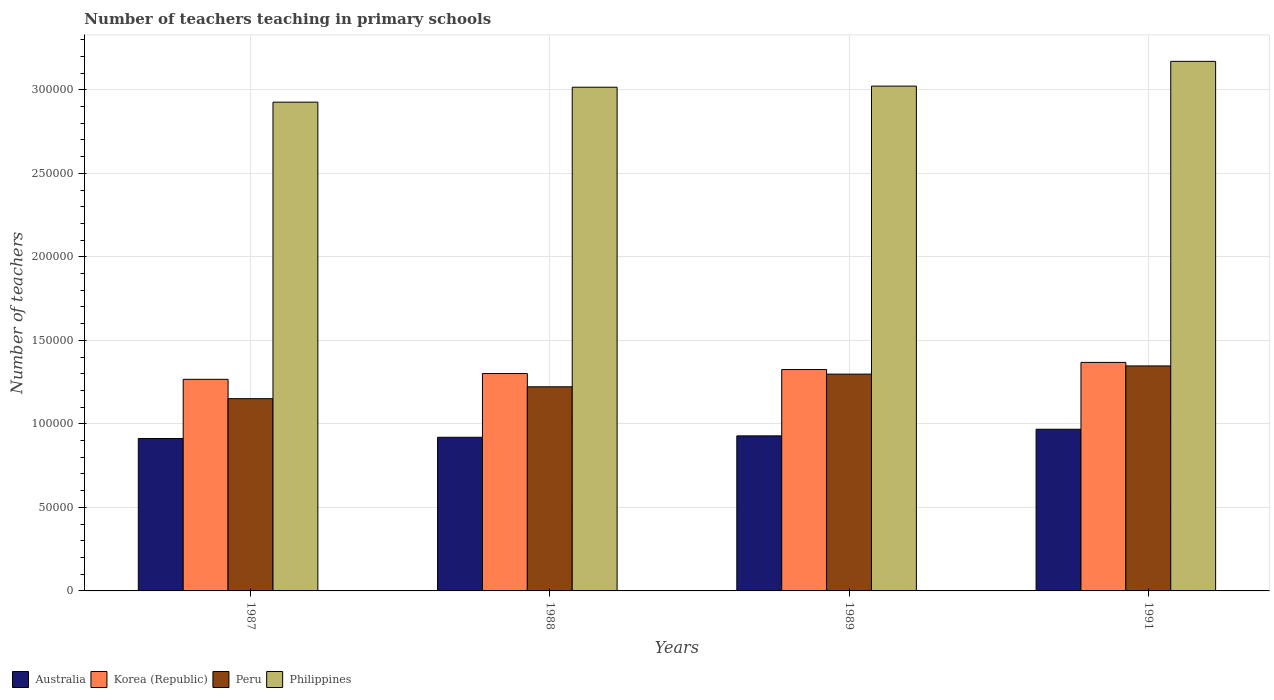How many different coloured bars are there?
Give a very brief answer. 4. How many groups of bars are there?
Keep it short and to the point. 4. How many bars are there on the 4th tick from the left?
Your answer should be very brief. 4. In how many cases, is the number of bars for a given year not equal to the number of legend labels?
Keep it short and to the point. 0. What is the number of teachers teaching in primary schools in Korea (Republic) in 1987?
Make the answer very short. 1.27e+05. Across all years, what is the maximum number of teachers teaching in primary schools in Australia?
Your answer should be very brief. 9.68e+04. Across all years, what is the minimum number of teachers teaching in primary schools in Philippines?
Make the answer very short. 2.93e+05. What is the total number of teachers teaching in primary schools in Philippines in the graph?
Your answer should be very brief. 1.21e+06. What is the difference between the number of teachers teaching in primary schools in Peru in 1987 and that in 1988?
Your response must be concise. -7106. What is the difference between the number of teachers teaching in primary schools in Korea (Republic) in 1987 and the number of teachers teaching in primary schools in Australia in 1991?
Offer a very short reply. 2.99e+04. What is the average number of teachers teaching in primary schools in Korea (Republic) per year?
Ensure brevity in your answer.  1.32e+05. In the year 1987, what is the difference between the number of teachers teaching in primary schools in Australia and number of teachers teaching in primary schools in Peru?
Ensure brevity in your answer.  -2.38e+04. In how many years, is the number of teachers teaching in primary schools in Peru greater than 260000?
Your answer should be compact. 0. What is the ratio of the number of teachers teaching in primary schools in Philippines in 1987 to that in 1988?
Provide a succinct answer. 0.97. Is the number of teachers teaching in primary schools in Korea (Republic) in 1987 less than that in 1991?
Your answer should be compact. Yes. What is the difference between the highest and the second highest number of teachers teaching in primary schools in Peru?
Ensure brevity in your answer.  4894. What is the difference between the highest and the lowest number of teachers teaching in primary schools in Australia?
Offer a very short reply. 5527. Is the sum of the number of teachers teaching in primary schools in Korea (Republic) in 1989 and 1991 greater than the maximum number of teachers teaching in primary schools in Peru across all years?
Give a very brief answer. Yes. Is it the case that in every year, the sum of the number of teachers teaching in primary schools in Korea (Republic) and number of teachers teaching in primary schools in Philippines is greater than the sum of number of teachers teaching in primary schools in Australia and number of teachers teaching in primary schools in Peru?
Keep it short and to the point. Yes. How many bars are there?
Provide a short and direct response. 16. Are all the bars in the graph horizontal?
Make the answer very short. No. How many years are there in the graph?
Make the answer very short. 4. How are the legend labels stacked?
Keep it short and to the point. Horizontal. What is the title of the graph?
Offer a very short reply. Number of teachers teaching in primary schools. Does "West Bank and Gaza" appear as one of the legend labels in the graph?
Ensure brevity in your answer.  No. What is the label or title of the X-axis?
Ensure brevity in your answer.  Years. What is the label or title of the Y-axis?
Give a very brief answer. Number of teachers. What is the Number of teachers in Australia in 1987?
Keep it short and to the point. 9.13e+04. What is the Number of teachers in Korea (Republic) in 1987?
Provide a succinct answer. 1.27e+05. What is the Number of teachers of Peru in 1987?
Make the answer very short. 1.15e+05. What is the Number of teachers of Philippines in 1987?
Your response must be concise. 2.93e+05. What is the Number of teachers of Australia in 1988?
Provide a succinct answer. 9.20e+04. What is the Number of teachers of Korea (Republic) in 1988?
Make the answer very short. 1.30e+05. What is the Number of teachers in Peru in 1988?
Provide a succinct answer. 1.22e+05. What is the Number of teachers of Philippines in 1988?
Offer a terse response. 3.02e+05. What is the Number of teachers in Australia in 1989?
Keep it short and to the point. 9.28e+04. What is the Number of teachers of Korea (Republic) in 1989?
Provide a short and direct response. 1.33e+05. What is the Number of teachers of Peru in 1989?
Ensure brevity in your answer.  1.30e+05. What is the Number of teachers of Philippines in 1989?
Provide a succinct answer. 3.02e+05. What is the Number of teachers of Australia in 1991?
Make the answer very short. 9.68e+04. What is the Number of teachers in Korea (Republic) in 1991?
Offer a very short reply. 1.37e+05. What is the Number of teachers in Peru in 1991?
Give a very brief answer. 1.35e+05. What is the Number of teachers of Philippines in 1991?
Your response must be concise. 3.17e+05. Across all years, what is the maximum Number of teachers in Australia?
Your answer should be compact. 9.68e+04. Across all years, what is the maximum Number of teachers of Korea (Republic)?
Make the answer very short. 1.37e+05. Across all years, what is the maximum Number of teachers of Peru?
Your response must be concise. 1.35e+05. Across all years, what is the maximum Number of teachers in Philippines?
Offer a terse response. 3.17e+05. Across all years, what is the minimum Number of teachers in Australia?
Ensure brevity in your answer.  9.13e+04. Across all years, what is the minimum Number of teachers in Korea (Republic)?
Make the answer very short. 1.27e+05. Across all years, what is the minimum Number of teachers in Peru?
Give a very brief answer. 1.15e+05. Across all years, what is the minimum Number of teachers in Philippines?
Your answer should be very brief. 2.93e+05. What is the total Number of teachers of Australia in the graph?
Offer a very short reply. 3.73e+05. What is the total Number of teachers of Korea (Republic) in the graph?
Keep it short and to the point. 5.26e+05. What is the total Number of teachers in Peru in the graph?
Make the answer very short. 5.02e+05. What is the total Number of teachers of Philippines in the graph?
Ensure brevity in your answer.  1.21e+06. What is the difference between the Number of teachers in Australia in 1987 and that in 1988?
Your answer should be very brief. -727. What is the difference between the Number of teachers of Korea (Republic) in 1987 and that in 1988?
Your answer should be very brief. -3465. What is the difference between the Number of teachers in Peru in 1987 and that in 1988?
Offer a very short reply. -7106. What is the difference between the Number of teachers in Philippines in 1987 and that in 1988?
Give a very brief answer. -8928. What is the difference between the Number of teachers of Australia in 1987 and that in 1989?
Offer a very short reply. -1568. What is the difference between the Number of teachers of Korea (Republic) in 1987 and that in 1989?
Offer a terse response. -5850. What is the difference between the Number of teachers in Peru in 1987 and that in 1989?
Give a very brief answer. -1.47e+04. What is the difference between the Number of teachers in Philippines in 1987 and that in 1989?
Offer a very short reply. -9593. What is the difference between the Number of teachers in Australia in 1987 and that in 1991?
Make the answer very short. -5527. What is the difference between the Number of teachers in Korea (Republic) in 1987 and that in 1991?
Make the answer very short. -1.01e+04. What is the difference between the Number of teachers of Peru in 1987 and that in 1991?
Offer a very short reply. -1.96e+04. What is the difference between the Number of teachers of Philippines in 1987 and that in 1991?
Keep it short and to the point. -2.44e+04. What is the difference between the Number of teachers in Australia in 1988 and that in 1989?
Give a very brief answer. -841. What is the difference between the Number of teachers of Korea (Republic) in 1988 and that in 1989?
Give a very brief answer. -2385. What is the difference between the Number of teachers in Peru in 1988 and that in 1989?
Offer a very short reply. -7594. What is the difference between the Number of teachers in Philippines in 1988 and that in 1989?
Your answer should be compact. -665. What is the difference between the Number of teachers of Australia in 1988 and that in 1991?
Provide a succinct answer. -4800. What is the difference between the Number of teachers in Korea (Republic) in 1988 and that in 1991?
Keep it short and to the point. -6658. What is the difference between the Number of teachers in Peru in 1988 and that in 1991?
Keep it short and to the point. -1.25e+04. What is the difference between the Number of teachers in Philippines in 1988 and that in 1991?
Offer a very short reply. -1.55e+04. What is the difference between the Number of teachers of Australia in 1989 and that in 1991?
Your answer should be compact. -3959. What is the difference between the Number of teachers of Korea (Republic) in 1989 and that in 1991?
Offer a terse response. -4273. What is the difference between the Number of teachers in Peru in 1989 and that in 1991?
Make the answer very short. -4894. What is the difference between the Number of teachers of Philippines in 1989 and that in 1991?
Offer a very short reply. -1.48e+04. What is the difference between the Number of teachers of Australia in 1987 and the Number of teachers of Korea (Republic) in 1988?
Your response must be concise. -3.89e+04. What is the difference between the Number of teachers of Australia in 1987 and the Number of teachers of Peru in 1988?
Make the answer very short. -3.09e+04. What is the difference between the Number of teachers of Australia in 1987 and the Number of teachers of Philippines in 1988?
Your answer should be very brief. -2.10e+05. What is the difference between the Number of teachers in Korea (Republic) in 1987 and the Number of teachers in Peru in 1988?
Your answer should be compact. 4478. What is the difference between the Number of teachers in Korea (Republic) in 1987 and the Number of teachers in Philippines in 1988?
Ensure brevity in your answer.  -1.75e+05. What is the difference between the Number of teachers in Peru in 1987 and the Number of teachers in Philippines in 1988?
Give a very brief answer. -1.86e+05. What is the difference between the Number of teachers in Australia in 1987 and the Number of teachers in Korea (Republic) in 1989?
Your answer should be very brief. -4.13e+04. What is the difference between the Number of teachers of Australia in 1987 and the Number of teachers of Peru in 1989?
Ensure brevity in your answer.  -3.85e+04. What is the difference between the Number of teachers of Australia in 1987 and the Number of teachers of Philippines in 1989?
Make the answer very short. -2.11e+05. What is the difference between the Number of teachers of Korea (Republic) in 1987 and the Number of teachers of Peru in 1989?
Provide a short and direct response. -3116. What is the difference between the Number of teachers of Korea (Republic) in 1987 and the Number of teachers of Philippines in 1989?
Your answer should be compact. -1.76e+05. What is the difference between the Number of teachers in Peru in 1987 and the Number of teachers in Philippines in 1989?
Provide a short and direct response. -1.87e+05. What is the difference between the Number of teachers in Australia in 1987 and the Number of teachers in Korea (Republic) in 1991?
Your response must be concise. -4.55e+04. What is the difference between the Number of teachers of Australia in 1987 and the Number of teachers of Peru in 1991?
Give a very brief answer. -4.34e+04. What is the difference between the Number of teachers in Australia in 1987 and the Number of teachers in Philippines in 1991?
Your answer should be compact. -2.26e+05. What is the difference between the Number of teachers in Korea (Republic) in 1987 and the Number of teachers in Peru in 1991?
Give a very brief answer. -8010. What is the difference between the Number of teachers in Korea (Republic) in 1987 and the Number of teachers in Philippines in 1991?
Your answer should be compact. -1.90e+05. What is the difference between the Number of teachers in Peru in 1987 and the Number of teachers in Philippines in 1991?
Keep it short and to the point. -2.02e+05. What is the difference between the Number of teachers of Australia in 1988 and the Number of teachers of Korea (Republic) in 1989?
Make the answer very short. -4.05e+04. What is the difference between the Number of teachers in Australia in 1988 and the Number of teachers in Peru in 1989?
Offer a terse response. -3.78e+04. What is the difference between the Number of teachers in Australia in 1988 and the Number of teachers in Philippines in 1989?
Your answer should be very brief. -2.10e+05. What is the difference between the Number of teachers of Korea (Republic) in 1988 and the Number of teachers of Peru in 1989?
Your answer should be compact. 349. What is the difference between the Number of teachers of Korea (Republic) in 1988 and the Number of teachers of Philippines in 1989?
Make the answer very short. -1.72e+05. What is the difference between the Number of teachers in Peru in 1988 and the Number of teachers in Philippines in 1989?
Your answer should be very brief. -1.80e+05. What is the difference between the Number of teachers of Australia in 1988 and the Number of teachers of Korea (Republic) in 1991?
Offer a terse response. -4.48e+04. What is the difference between the Number of teachers in Australia in 1988 and the Number of teachers in Peru in 1991?
Provide a short and direct response. -4.27e+04. What is the difference between the Number of teachers of Australia in 1988 and the Number of teachers of Philippines in 1991?
Ensure brevity in your answer.  -2.25e+05. What is the difference between the Number of teachers of Korea (Republic) in 1988 and the Number of teachers of Peru in 1991?
Provide a succinct answer. -4545. What is the difference between the Number of teachers of Korea (Republic) in 1988 and the Number of teachers of Philippines in 1991?
Your answer should be very brief. -1.87e+05. What is the difference between the Number of teachers in Peru in 1988 and the Number of teachers in Philippines in 1991?
Provide a short and direct response. -1.95e+05. What is the difference between the Number of teachers in Australia in 1989 and the Number of teachers in Korea (Republic) in 1991?
Keep it short and to the point. -4.40e+04. What is the difference between the Number of teachers of Australia in 1989 and the Number of teachers of Peru in 1991?
Provide a succinct answer. -4.19e+04. What is the difference between the Number of teachers of Australia in 1989 and the Number of teachers of Philippines in 1991?
Keep it short and to the point. -2.24e+05. What is the difference between the Number of teachers in Korea (Republic) in 1989 and the Number of teachers in Peru in 1991?
Your answer should be compact. -2160. What is the difference between the Number of teachers of Korea (Republic) in 1989 and the Number of teachers of Philippines in 1991?
Your answer should be compact. -1.84e+05. What is the difference between the Number of teachers in Peru in 1989 and the Number of teachers in Philippines in 1991?
Ensure brevity in your answer.  -1.87e+05. What is the average Number of teachers in Australia per year?
Provide a succinct answer. 9.32e+04. What is the average Number of teachers in Korea (Republic) per year?
Offer a very short reply. 1.32e+05. What is the average Number of teachers in Peru per year?
Your answer should be very brief. 1.25e+05. What is the average Number of teachers of Philippines per year?
Make the answer very short. 3.03e+05. In the year 1987, what is the difference between the Number of teachers of Australia and Number of teachers of Korea (Republic)?
Offer a terse response. -3.54e+04. In the year 1987, what is the difference between the Number of teachers in Australia and Number of teachers in Peru?
Keep it short and to the point. -2.38e+04. In the year 1987, what is the difference between the Number of teachers of Australia and Number of teachers of Philippines?
Keep it short and to the point. -2.01e+05. In the year 1987, what is the difference between the Number of teachers in Korea (Republic) and Number of teachers in Peru?
Offer a terse response. 1.16e+04. In the year 1987, what is the difference between the Number of teachers of Korea (Republic) and Number of teachers of Philippines?
Offer a terse response. -1.66e+05. In the year 1987, what is the difference between the Number of teachers in Peru and Number of teachers in Philippines?
Provide a succinct answer. -1.78e+05. In the year 1988, what is the difference between the Number of teachers in Australia and Number of teachers in Korea (Republic)?
Provide a short and direct response. -3.82e+04. In the year 1988, what is the difference between the Number of teachers in Australia and Number of teachers in Peru?
Your response must be concise. -3.02e+04. In the year 1988, what is the difference between the Number of teachers of Australia and Number of teachers of Philippines?
Offer a very short reply. -2.10e+05. In the year 1988, what is the difference between the Number of teachers of Korea (Republic) and Number of teachers of Peru?
Give a very brief answer. 7943. In the year 1988, what is the difference between the Number of teachers in Korea (Republic) and Number of teachers in Philippines?
Offer a terse response. -1.71e+05. In the year 1988, what is the difference between the Number of teachers of Peru and Number of teachers of Philippines?
Provide a short and direct response. -1.79e+05. In the year 1989, what is the difference between the Number of teachers in Australia and Number of teachers in Korea (Republic)?
Ensure brevity in your answer.  -3.97e+04. In the year 1989, what is the difference between the Number of teachers in Australia and Number of teachers in Peru?
Offer a terse response. -3.70e+04. In the year 1989, what is the difference between the Number of teachers of Australia and Number of teachers of Philippines?
Make the answer very short. -2.09e+05. In the year 1989, what is the difference between the Number of teachers of Korea (Republic) and Number of teachers of Peru?
Provide a succinct answer. 2734. In the year 1989, what is the difference between the Number of teachers in Korea (Republic) and Number of teachers in Philippines?
Your answer should be compact. -1.70e+05. In the year 1989, what is the difference between the Number of teachers in Peru and Number of teachers in Philippines?
Offer a very short reply. -1.72e+05. In the year 1991, what is the difference between the Number of teachers of Australia and Number of teachers of Korea (Republic)?
Provide a short and direct response. -4.00e+04. In the year 1991, what is the difference between the Number of teachers in Australia and Number of teachers in Peru?
Offer a very short reply. -3.79e+04. In the year 1991, what is the difference between the Number of teachers of Australia and Number of teachers of Philippines?
Ensure brevity in your answer.  -2.20e+05. In the year 1991, what is the difference between the Number of teachers of Korea (Republic) and Number of teachers of Peru?
Your answer should be very brief. 2113. In the year 1991, what is the difference between the Number of teachers of Korea (Republic) and Number of teachers of Philippines?
Offer a very short reply. -1.80e+05. In the year 1991, what is the difference between the Number of teachers of Peru and Number of teachers of Philippines?
Give a very brief answer. -1.82e+05. What is the ratio of the Number of teachers in Australia in 1987 to that in 1988?
Provide a short and direct response. 0.99. What is the ratio of the Number of teachers in Korea (Republic) in 1987 to that in 1988?
Offer a terse response. 0.97. What is the ratio of the Number of teachers in Peru in 1987 to that in 1988?
Offer a terse response. 0.94. What is the ratio of the Number of teachers of Philippines in 1987 to that in 1988?
Offer a very short reply. 0.97. What is the ratio of the Number of teachers of Australia in 1987 to that in 1989?
Your response must be concise. 0.98. What is the ratio of the Number of teachers in Korea (Republic) in 1987 to that in 1989?
Make the answer very short. 0.96. What is the ratio of the Number of teachers of Peru in 1987 to that in 1989?
Give a very brief answer. 0.89. What is the ratio of the Number of teachers in Philippines in 1987 to that in 1989?
Keep it short and to the point. 0.97. What is the ratio of the Number of teachers of Australia in 1987 to that in 1991?
Make the answer very short. 0.94. What is the ratio of the Number of teachers in Korea (Republic) in 1987 to that in 1991?
Your response must be concise. 0.93. What is the ratio of the Number of teachers in Peru in 1987 to that in 1991?
Ensure brevity in your answer.  0.85. What is the ratio of the Number of teachers in Philippines in 1987 to that in 1991?
Make the answer very short. 0.92. What is the ratio of the Number of teachers in Australia in 1988 to that in 1989?
Make the answer very short. 0.99. What is the ratio of the Number of teachers in Korea (Republic) in 1988 to that in 1989?
Provide a short and direct response. 0.98. What is the ratio of the Number of teachers of Peru in 1988 to that in 1989?
Keep it short and to the point. 0.94. What is the ratio of the Number of teachers of Philippines in 1988 to that in 1989?
Ensure brevity in your answer.  1. What is the ratio of the Number of teachers in Australia in 1988 to that in 1991?
Offer a very short reply. 0.95. What is the ratio of the Number of teachers in Korea (Republic) in 1988 to that in 1991?
Your answer should be very brief. 0.95. What is the ratio of the Number of teachers of Peru in 1988 to that in 1991?
Your answer should be very brief. 0.91. What is the ratio of the Number of teachers in Philippines in 1988 to that in 1991?
Give a very brief answer. 0.95. What is the ratio of the Number of teachers of Australia in 1989 to that in 1991?
Provide a succinct answer. 0.96. What is the ratio of the Number of teachers in Korea (Republic) in 1989 to that in 1991?
Your answer should be compact. 0.97. What is the ratio of the Number of teachers in Peru in 1989 to that in 1991?
Give a very brief answer. 0.96. What is the ratio of the Number of teachers of Philippines in 1989 to that in 1991?
Ensure brevity in your answer.  0.95. What is the difference between the highest and the second highest Number of teachers in Australia?
Ensure brevity in your answer.  3959. What is the difference between the highest and the second highest Number of teachers in Korea (Republic)?
Offer a very short reply. 4273. What is the difference between the highest and the second highest Number of teachers of Peru?
Provide a short and direct response. 4894. What is the difference between the highest and the second highest Number of teachers of Philippines?
Your answer should be very brief. 1.48e+04. What is the difference between the highest and the lowest Number of teachers of Australia?
Ensure brevity in your answer.  5527. What is the difference between the highest and the lowest Number of teachers in Korea (Republic)?
Give a very brief answer. 1.01e+04. What is the difference between the highest and the lowest Number of teachers in Peru?
Your answer should be very brief. 1.96e+04. What is the difference between the highest and the lowest Number of teachers of Philippines?
Your answer should be very brief. 2.44e+04. 